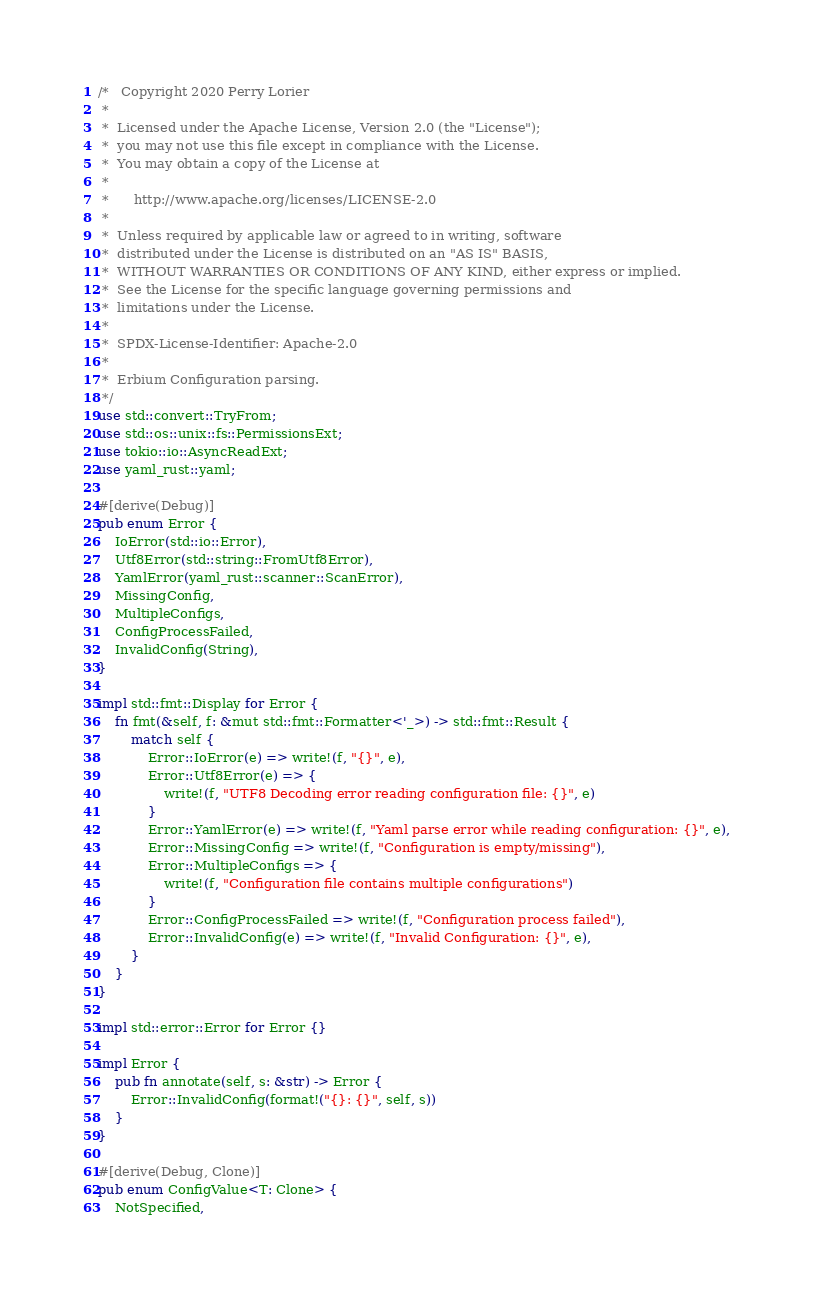Convert code to text. <code><loc_0><loc_0><loc_500><loc_500><_Rust_>/*   Copyright 2020 Perry Lorier
 *
 *  Licensed under the Apache License, Version 2.0 (the "License");
 *  you may not use this file except in compliance with the License.
 *  You may obtain a copy of the License at
 *
 *      http://www.apache.org/licenses/LICENSE-2.0
 *
 *  Unless required by applicable law or agreed to in writing, software
 *  distributed under the License is distributed on an "AS IS" BASIS,
 *  WITHOUT WARRANTIES OR CONDITIONS OF ANY KIND, either express or implied.
 *  See the License for the specific language governing permissions and
 *  limitations under the License.
 *
 *  SPDX-License-Identifier: Apache-2.0
 *
 *  Erbium Configuration parsing.
 */
use std::convert::TryFrom;
use std::os::unix::fs::PermissionsExt;
use tokio::io::AsyncReadExt;
use yaml_rust::yaml;

#[derive(Debug)]
pub enum Error {
    IoError(std::io::Error),
    Utf8Error(std::string::FromUtf8Error),
    YamlError(yaml_rust::scanner::ScanError),
    MissingConfig,
    MultipleConfigs,
    ConfigProcessFailed,
    InvalidConfig(String),
}

impl std::fmt::Display for Error {
    fn fmt(&self, f: &mut std::fmt::Formatter<'_>) -> std::fmt::Result {
        match self {
            Error::IoError(e) => write!(f, "{}", e),
            Error::Utf8Error(e) => {
                write!(f, "UTF8 Decoding error reading configuration file: {}", e)
            }
            Error::YamlError(e) => write!(f, "Yaml parse error while reading configuration: {}", e),
            Error::MissingConfig => write!(f, "Configuration is empty/missing"),
            Error::MultipleConfigs => {
                write!(f, "Configuration file contains multiple configurations")
            }
            Error::ConfigProcessFailed => write!(f, "Configuration process failed"),
            Error::InvalidConfig(e) => write!(f, "Invalid Configuration: {}", e),
        }
    }
}

impl std::error::Error for Error {}

impl Error {
    pub fn annotate(self, s: &str) -> Error {
        Error::InvalidConfig(format!("{}: {}", self, s))
    }
}

#[derive(Debug, Clone)]
pub enum ConfigValue<T: Clone> {
    NotSpecified,</code> 